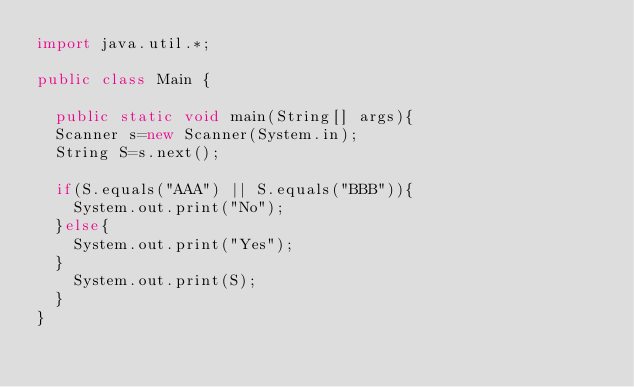Convert code to text. <code><loc_0><loc_0><loc_500><loc_500><_Java_>import java.util.*;
 
public class Main {
  
  public static void main(String[] args){
  Scanner s=new Scanner(System.in);
  String S=s.next();
  
  if(S.equals("AAA") || S.equals("BBB")){
    System.out.print("No");
  }else{
    System.out.print("Yes");
  }
    System.out.print(S);
  }
}
</code> 